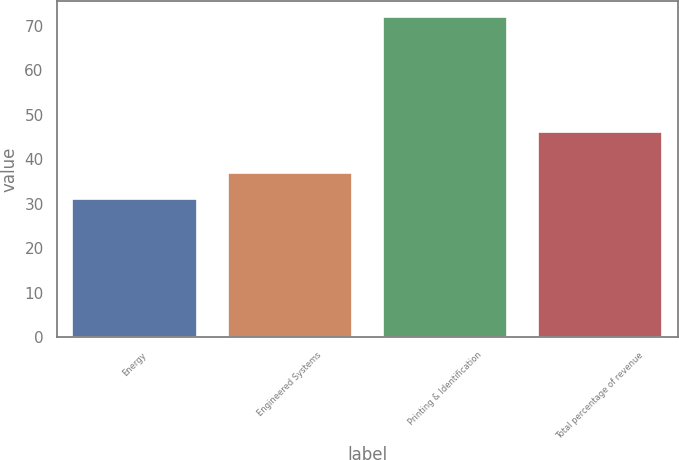Convert chart to OTSL. <chart><loc_0><loc_0><loc_500><loc_500><bar_chart><fcel>Energy<fcel>Engineered Systems<fcel>Printing & Identification<fcel>Total percentage of revenue<nl><fcel>31<fcel>37<fcel>72<fcel>46<nl></chart> 